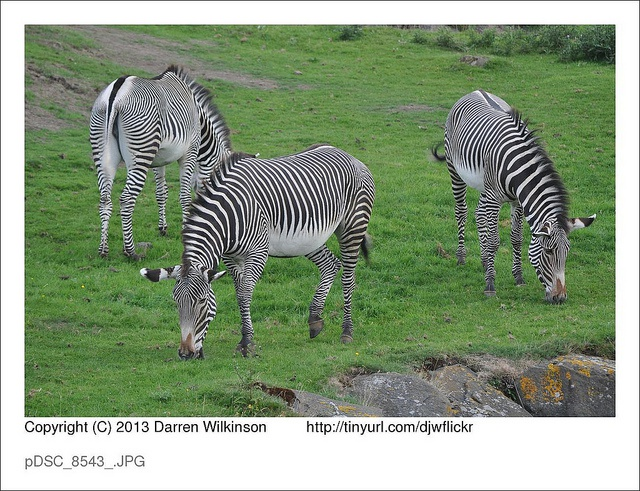Describe the objects in this image and their specific colors. I can see zebra in black, gray, darkgray, and lightgray tones, zebra in black, gray, darkgray, and lightgray tones, and zebra in black, darkgray, gray, and lightgray tones in this image. 